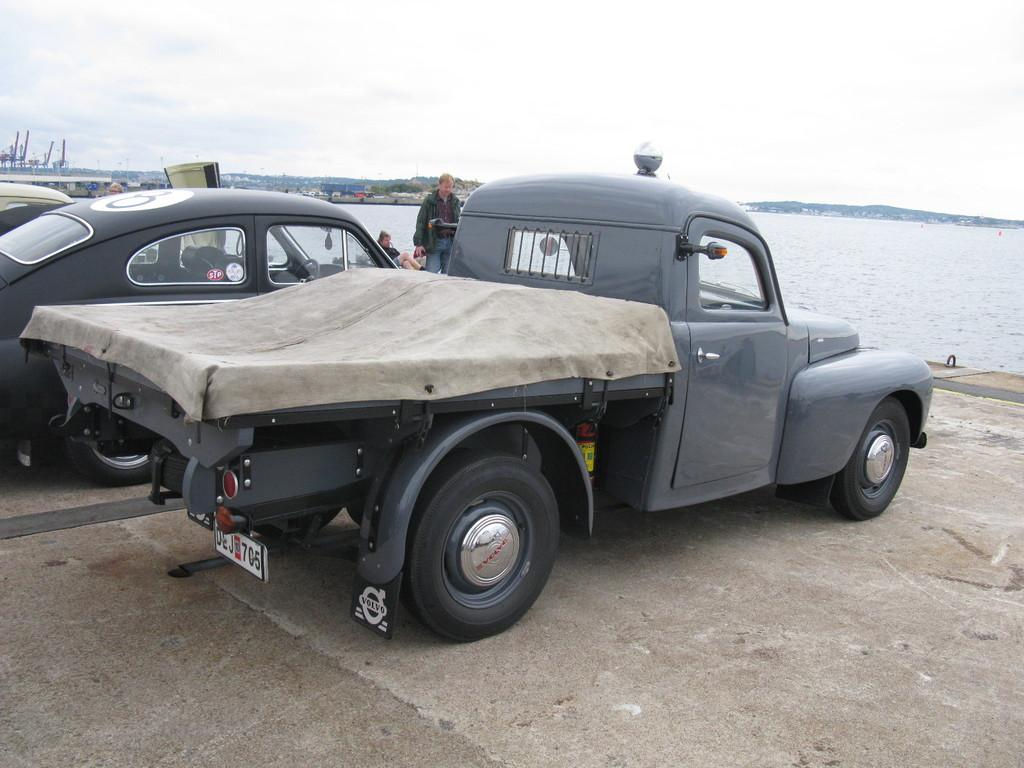What types of objects are present in the image? There are vehicles in the image. What can be seen in front of the vehicles? There are people in front of the vehicles. What is visible in the background of the image? Water, trees, buildings, mountains, and the sky are visible in the background of the image. What type of beef is being distributed in the image? There is no beef or distribution present in the image. How is the control system being managed in the image? There is no control system or management visible in the image. 